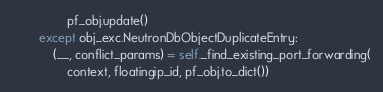Convert code to text. <code><loc_0><loc_0><loc_500><loc_500><_Python_>                pf_obj.update()
        except obj_exc.NeutronDbObjectDuplicateEntry:
            (__, conflict_params) = self._find_existing_port_forwarding(
                context, floatingip_id, pf_obj.to_dict())</code> 